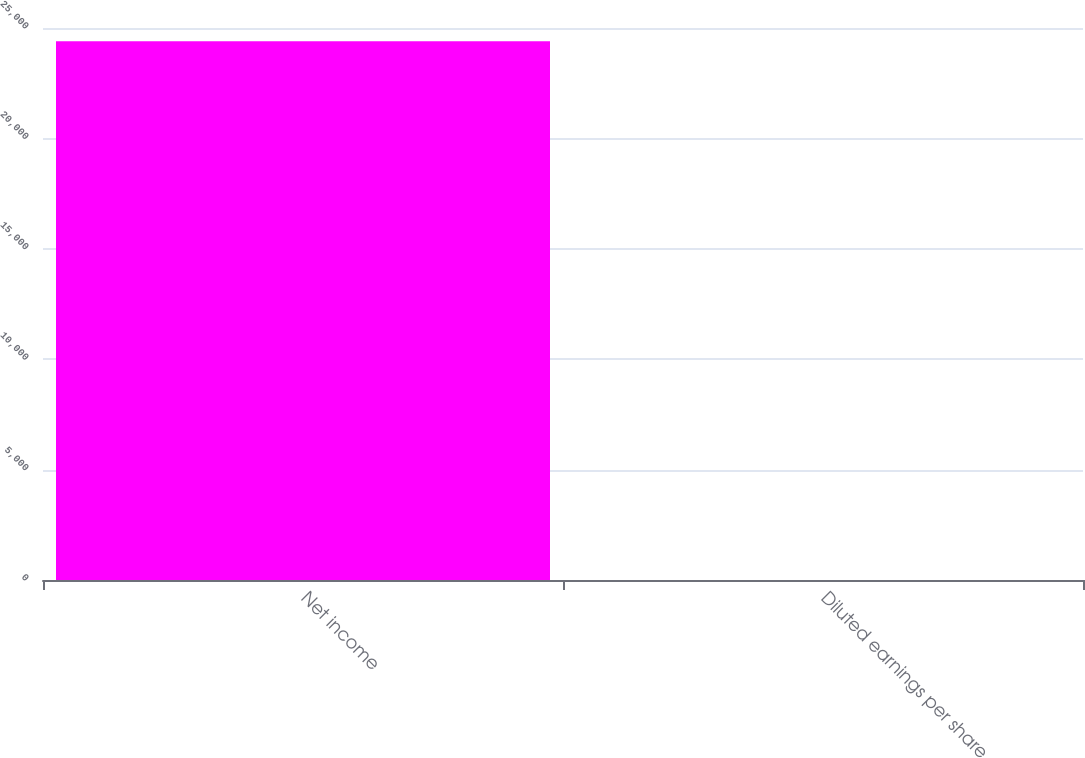Convert chart. <chart><loc_0><loc_0><loc_500><loc_500><bar_chart><fcel>Net income<fcel>Diluted earnings per share<nl><fcel>24395<fcel>0.34<nl></chart> 